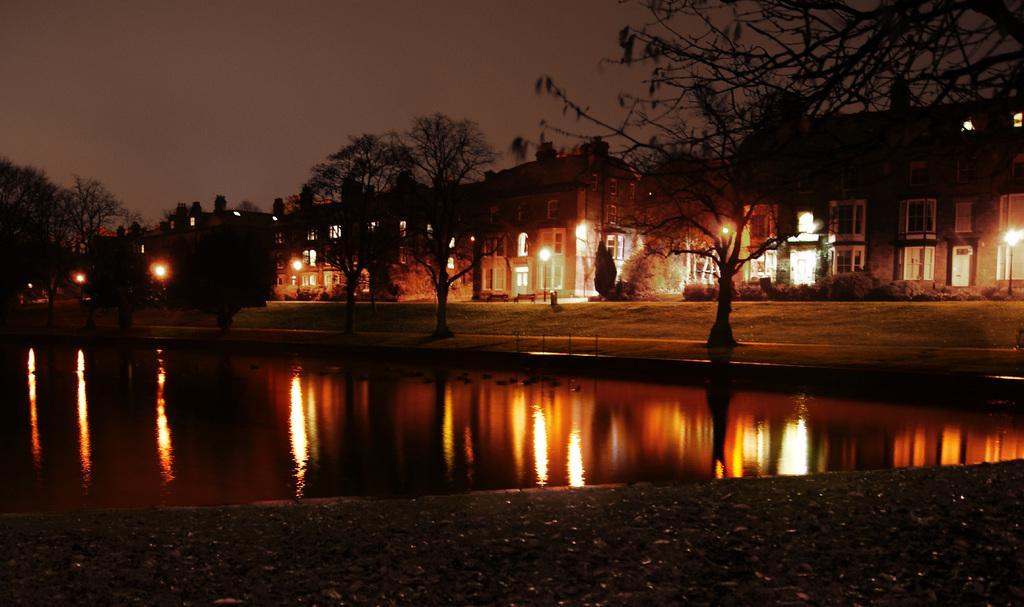In one or two sentences, can you explain what this image depicts? In the image we can see there are buildings and these are the windows of the building. These are the light poles, this is a water, plant, trees and a spy, these are the benches. 